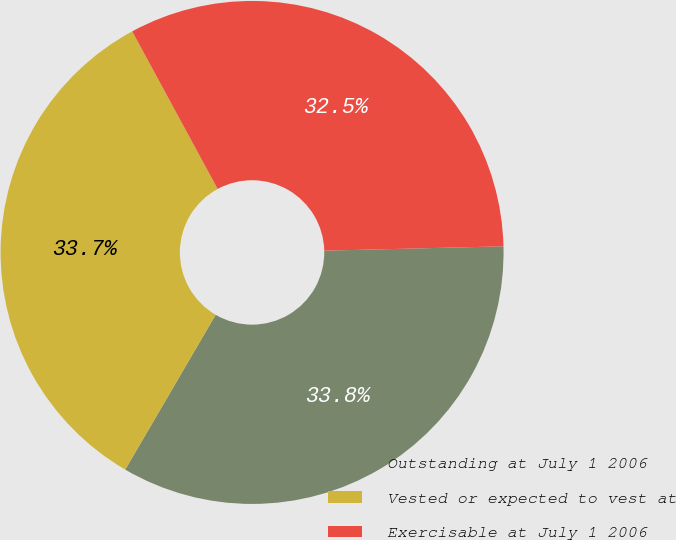Convert chart. <chart><loc_0><loc_0><loc_500><loc_500><pie_chart><fcel>Outstanding at July 1 2006<fcel>Vested or expected to vest at<fcel>Exercisable at July 1 2006<nl><fcel>33.8%<fcel>33.68%<fcel>32.52%<nl></chart> 